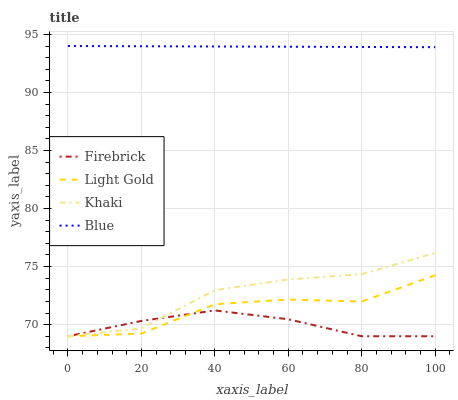Does Firebrick have the minimum area under the curve?
Answer yes or no. Yes. Does Blue have the maximum area under the curve?
Answer yes or no. Yes. Does Khaki have the minimum area under the curve?
Answer yes or no. No. Does Khaki have the maximum area under the curve?
Answer yes or no. No. Is Blue the smoothest?
Answer yes or no. Yes. Is Light Gold the roughest?
Answer yes or no. Yes. Is Firebrick the smoothest?
Answer yes or no. No. Is Firebrick the roughest?
Answer yes or no. No. Does Firebrick have the lowest value?
Answer yes or no. Yes. Does Blue have the highest value?
Answer yes or no. Yes. Does Khaki have the highest value?
Answer yes or no. No. Is Firebrick less than Blue?
Answer yes or no. Yes. Is Blue greater than Firebrick?
Answer yes or no. Yes. Does Light Gold intersect Firebrick?
Answer yes or no. Yes. Is Light Gold less than Firebrick?
Answer yes or no. No. Is Light Gold greater than Firebrick?
Answer yes or no. No. Does Firebrick intersect Blue?
Answer yes or no. No. 